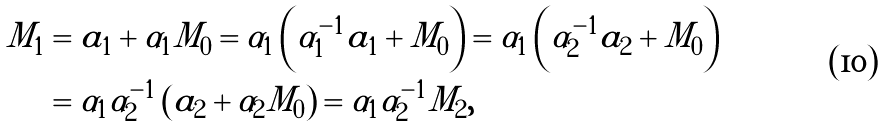<formula> <loc_0><loc_0><loc_500><loc_500>M _ { 1 } & = a _ { 1 } + \alpha _ { 1 } M _ { 0 } = \alpha _ { 1 } \left ( \alpha _ { 1 } ^ { - 1 } a _ { 1 } + M _ { 0 } \right ) = \alpha _ { 1 } \left ( \alpha _ { 2 } ^ { - 1 } a _ { 2 } + M _ { 0 } \right ) \\ & = \alpha _ { 1 } \alpha _ { 2 } ^ { - 1 } \left ( a _ { 2 } + \alpha _ { 2 } M _ { 0 } \right ) = \alpha _ { 1 } \alpha _ { 2 } ^ { - 1 } M _ { 2 } ,</formula> 